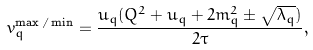Convert formula to latex. <formula><loc_0><loc_0><loc_500><loc_500>v _ { q } ^ { \max / \min } = \frac { u _ { q } ( Q ^ { 2 } + u _ { q } + 2 m _ { q } ^ { 2 } \pm \sqrt { \lambda _ { q } } ) } { 2 \tau } ,</formula> 